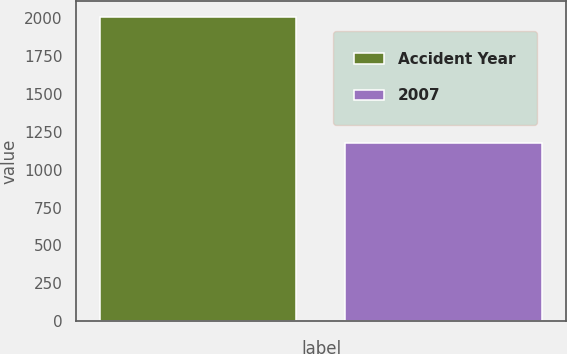Convert chart to OTSL. <chart><loc_0><loc_0><loc_500><loc_500><bar_chart><fcel>Accident Year<fcel>2007<nl><fcel>2011<fcel>1175<nl></chart> 